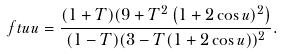Convert formula to latex. <formula><loc_0><loc_0><loc_500><loc_500>\ f t u u = \frac { ( 1 + T ) ( 9 + T ^ { 2 } \left ( 1 + 2 \cos u ) ^ { 2 } \right ) } { ( 1 - T ) ( 3 - T ( 1 + 2 \cos u ) ) ^ { 2 } } .</formula> 